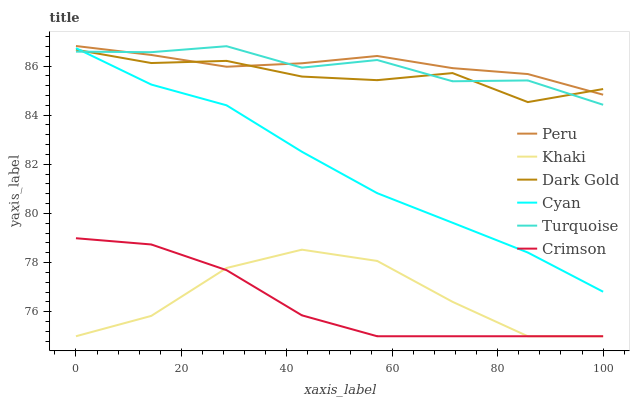Does Crimson have the minimum area under the curve?
Answer yes or no. Yes. Does Peru have the maximum area under the curve?
Answer yes or no. Yes. Does Khaki have the minimum area under the curve?
Answer yes or no. No. Does Khaki have the maximum area under the curve?
Answer yes or no. No. Is Peru the smoothest?
Answer yes or no. Yes. Is Khaki the roughest?
Answer yes or no. Yes. Is Dark Gold the smoothest?
Answer yes or no. No. Is Dark Gold the roughest?
Answer yes or no. No. Does Dark Gold have the lowest value?
Answer yes or no. No. Does Dark Gold have the highest value?
Answer yes or no. No. Is Crimson less than Cyan?
Answer yes or no. Yes. Is Peru greater than Crimson?
Answer yes or no. Yes. Does Crimson intersect Cyan?
Answer yes or no. No. 